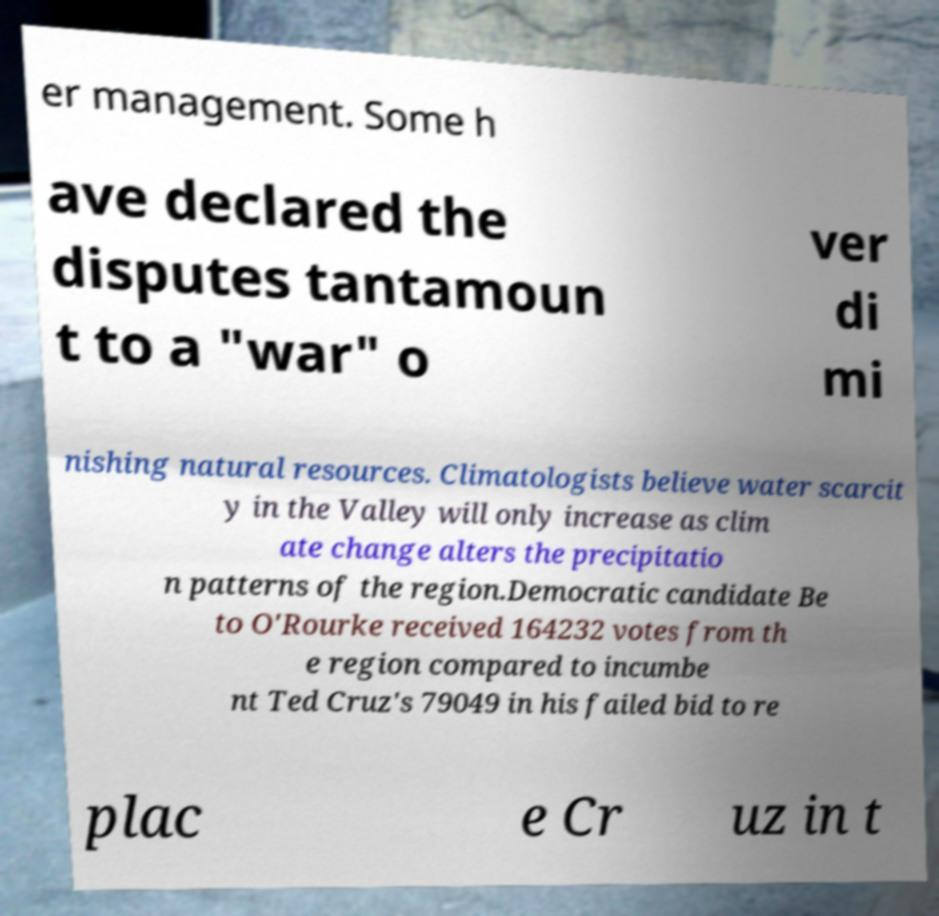Could you assist in decoding the text presented in this image and type it out clearly? er management. Some h ave declared the disputes tantamoun t to a "war" o ver di mi nishing natural resources. Climatologists believe water scarcit y in the Valley will only increase as clim ate change alters the precipitatio n patterns of the region.Democratic candidate Be to O'Rourke received 164232 votes from th e region compared to incumbe nt Ted Cruz's 79049 in his failed bid to re plac e Cr uz in t 